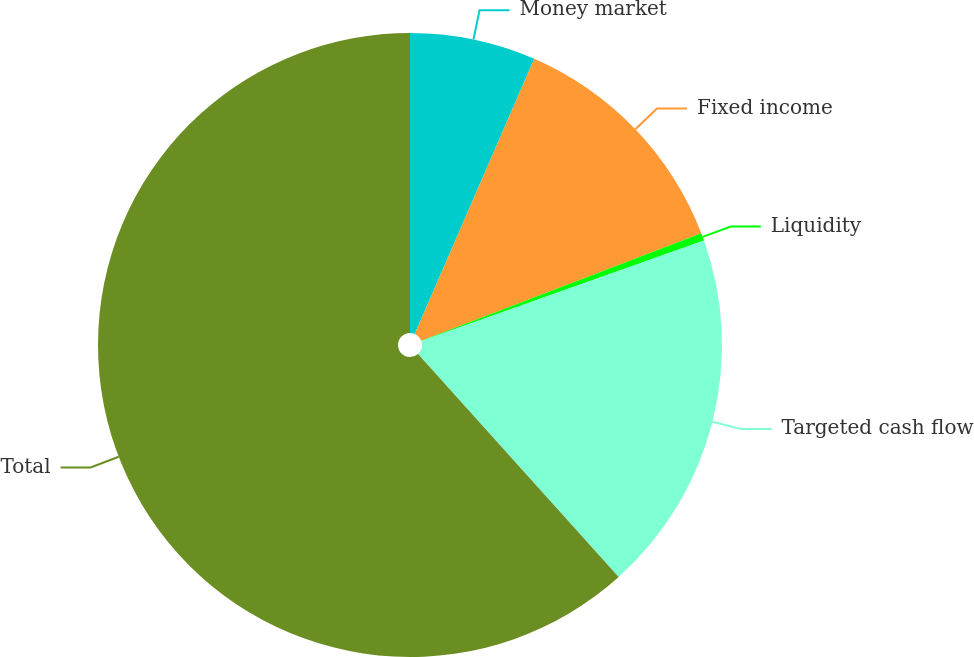Convert chart. <chart><loc_0><loc_0><loc_500><loc_500><pie_chart><fcel>Money market<fcel>Fixed income<fcel>Liquidity<fcel>Targeted cash flow<fcel>Total<nl><fcel>6.52%<fcel>12.65%<fcel>0.4%<fcel>18.77%<fcel>61.66%<nl></chart> 